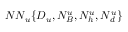<formula> <loc_0><loc_0><loc_500><loc_500>N N _ { u } \{ D _ { u } , N _ { B } ^ { u } , N _ { h } ^ { u } , N _ { d } ^ { u } \}</formula> 